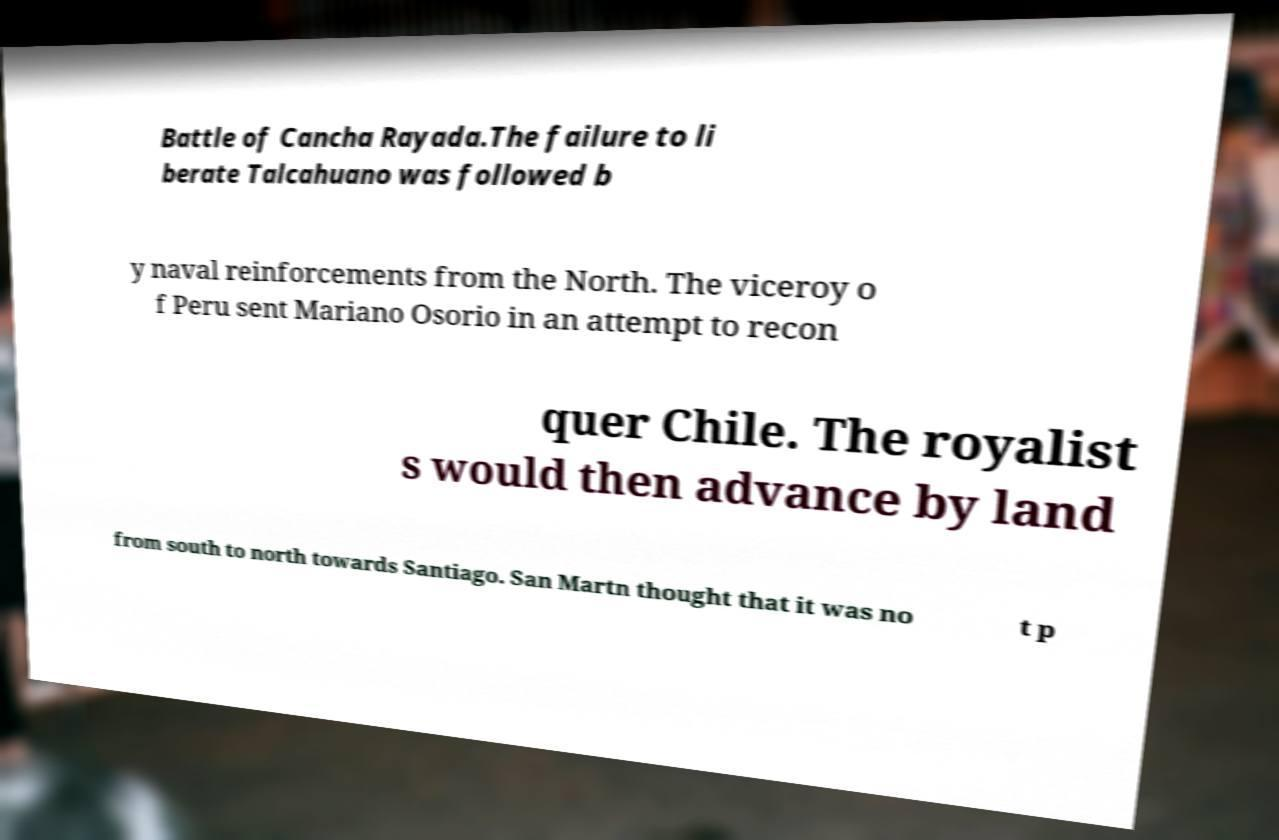Please read and relay the text visible in this image. What does it say? Battle of Cancha Rayada.The failure to li berate Talcahuano was followed b y naval reinforcements from the North. The viceroy o f Peru sent Mariano Osorio in an attempt to recon quer Chile. The royalist s would then advance by land from south to north towards Santiago. San Martn thought that it was no t p 